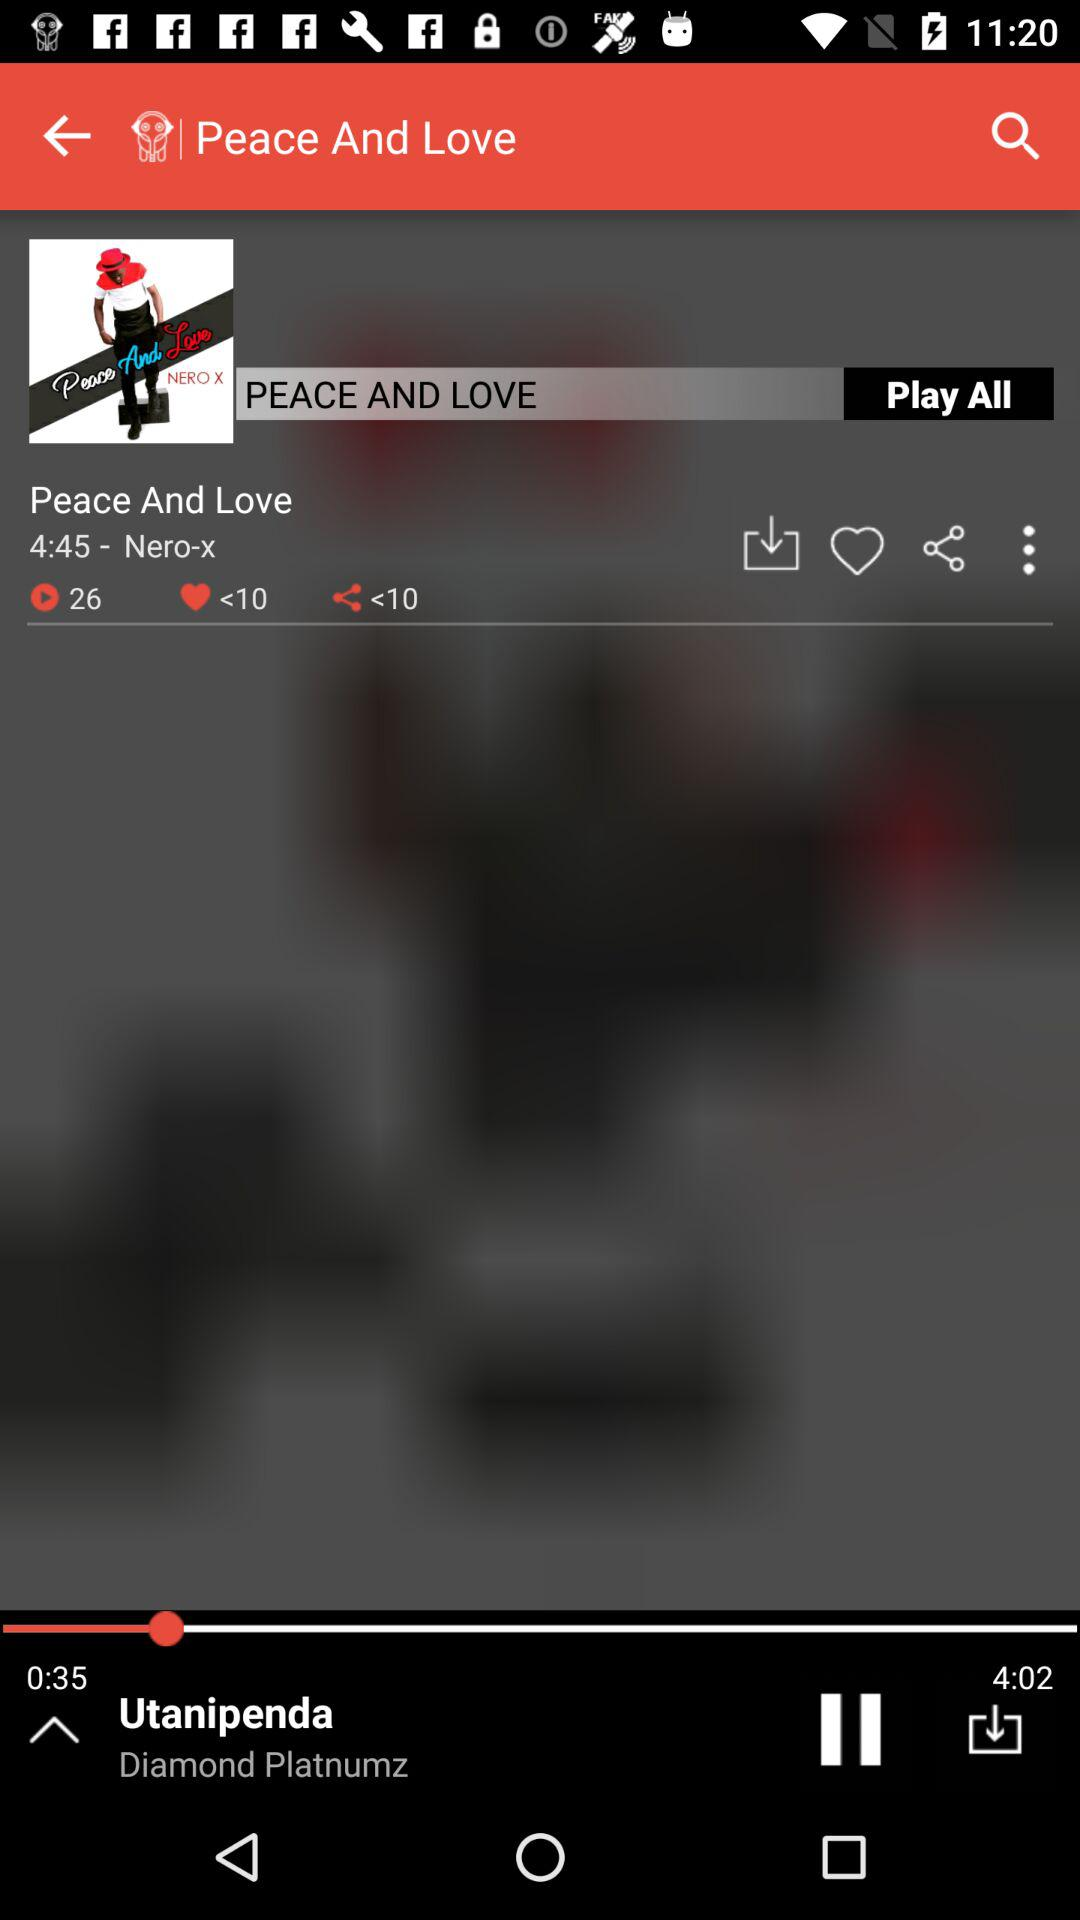What is the name of the song currently playing? The name of the song currently playing is Utanipenda. 